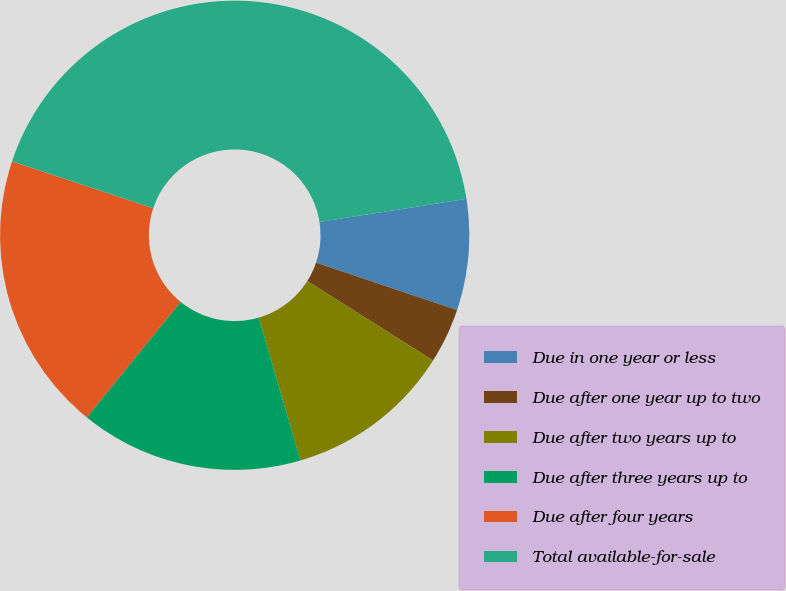<chart> <loc_0><loc_0><loc_500><loc_500><pie_chart><fcel>Due in one year or less<fcel>Due after one year up to two<fcel>Due after two years up to<fcel>Due after three years up to<fcel>Due after four years<fcel>Total available-for-sale<nl><fcel>7.65%<fcel>3.79%<fcel>11.52%<fcel>15.38%<fcel>19.24%<fcel>42.42%<nl></chart> 